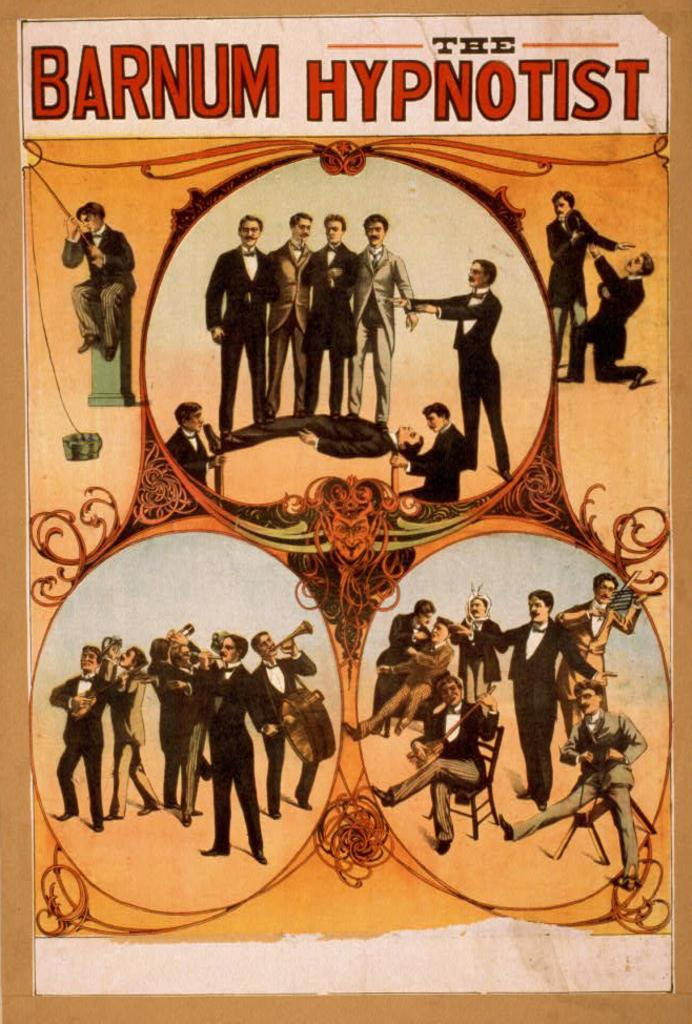<image>
Write a terse but informative summary of the picture. A poster for Barnum The Hypnotist shows several men playing instruments 